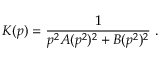Convert formula to latex. <formula><loc_0><loc_0><loc_500><loc_500>K ( p ) = \frac { 1 } { p ^ { 2 } A ( p ^ { 2 } ) ^ { 2 } + B ( p ^ { 2 } ) ^ { 2 } } .</formula> 